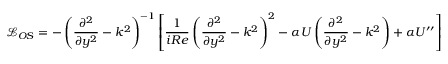Convert formula to latex. <formula><loc_0><loc_0><loc_500><loc_500>\mathcal { L } _ { O S } = - \left ( \frac { \partial ^ { 2 } } { \partial y ^ { 2 } } - k ^ { 2 } \right ) ^ { - 1 } \left [ \frac { 1 } { i R e } \left ( \frac { \partial ^ { 2 } } { \partial y ^ { 2 } } - k ^ { 2 } \right ) ^ { 2 } - \alpha U \left ( \frac { \partial ^ { 2 } } { \partial y ^ { 2 } } - k ^ { 2 } \right ) + \alpha U ^ { \prime \prime } \right ] ,</formula> 